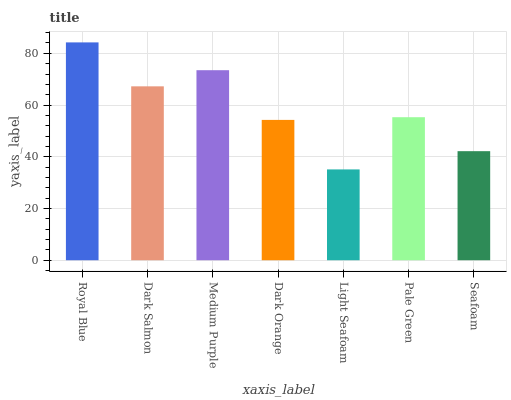Is Light Seafoam the minimum?
Answer yes or no. Yes. Is Royal Blue the maximum?
Answer yes or no. Yes. Is Dark Salmon the minimum?
Answer yes or no. No. Is Dark Salmon the maximum?
Answer yes or no. No. Is Royal Blue greater than Dark Salmon?
Answer yes or no. Yes. Is Dark Salmon less than Royal Blue?
Answer yes or no. Yes. Is Dark Salmon greater than Royal Blue?
Answer yes or no. No. Is Royal Blue less than Dark Salmon?
Answer yes or no. No. Is Pale Green the high median?
Answer yes or no. Yes. Is Pale Green the low median?
Answer yes or no. Yes. Is Royal Blue the high median?
Answer yes or no. No. Is Dark Salmon the low median?
Answer yes or no. No. 